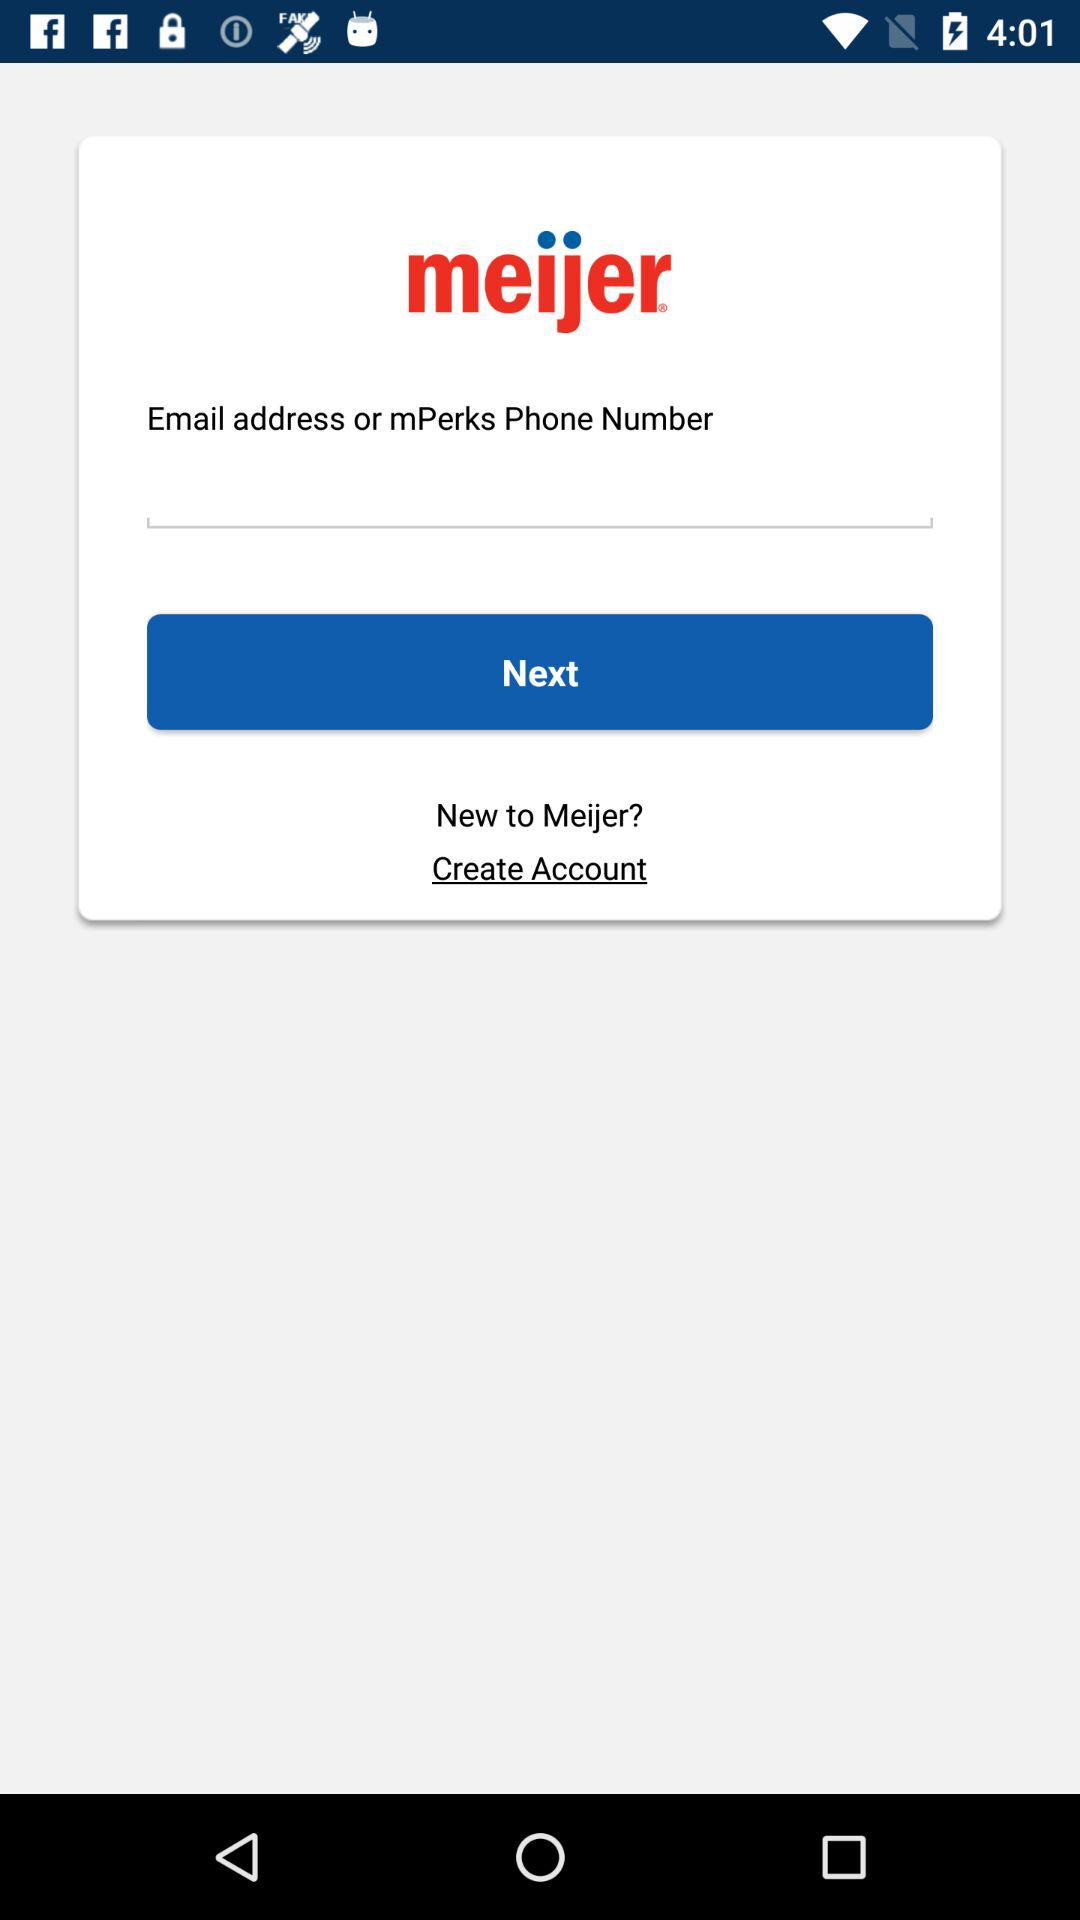What is the app title? The app title is "meijer". 